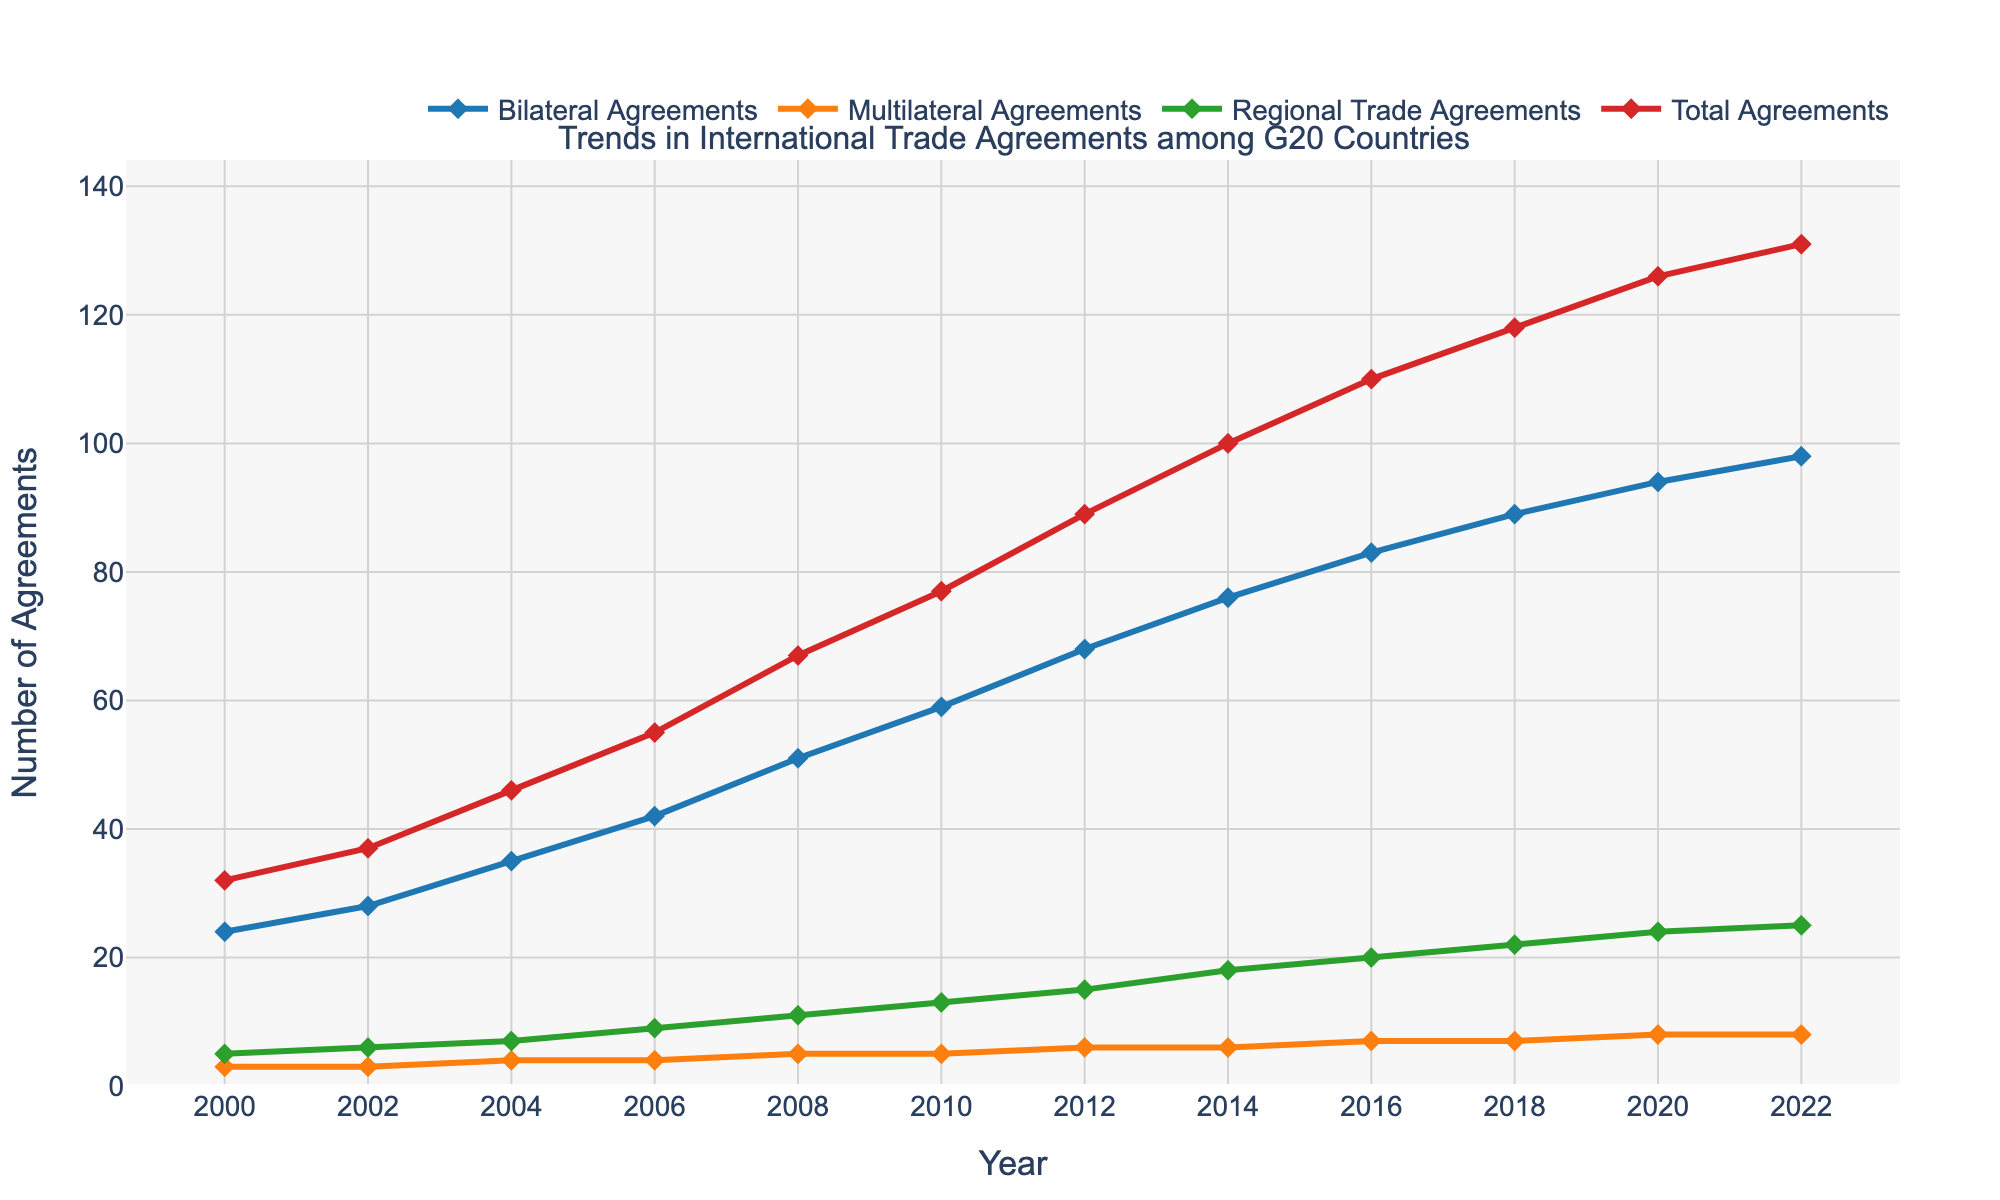What is the trend in the number of bilateral agreements from 2000 to 2022? Bilateral agreements show an increasing trend from 24 in 2000 to 98 in 2022.
Answer: Increasing trend How many multilateral agreements were there in 2016 and how does this compare to 2022? In 2016, there were 7 multilateral agreements and in 2022, there were 8. So, the number increased by 1.
Answer: Increased by 1 Which year had the highest total number of trade agreements? The year with the highest total number of trade agreements is 2022 with 131 agreements.
Answer: 2022 How did the number of regional trade agreements change between 2008 and 2020? In 2008, there were 11 regional trade agreements and in 2020, there were 24. So, the number increased by 13.
Answer: Increased by 13 What is the average increase in bilateral agreements per year from 2000 to 2022? The number of bilateral agreements increased from 24 in 2000 to 98 in 2022, a span of 22 years. The increase is 98 - 24 = 74. Therefore, the average increase per year is 74/22 ≈ 3.36.
Answer: Approximately 3.36 Between which years did the total number of agreements see the largest increase? The total number of trade agreements saw the largest increase between 2012 and 2014, increasing from 89 to 100, which is an increase of 11 agreements.
Answer: 2012 to 2014 What was the difference in the number of bilateral agreements between 2006 and 2018? In 2006, there were 42 bilateral agreements and in 2018, there were 89 bilateral agreements. The difference is 89 - 42 = 47.
Answer: 47 Which type of agreement shows the slowest rate of increase over the years? Multilateral agreements show the slowest rate of increase, starting with 3 in 2000 and growing to only 8 in 2022.
Answer: Multilateral Agreements What is the average number of regional trade agreements in the years 2000, 2004, 2008, 2012, 2016, and 2020? Adding the data points, 5, 7, 11, 15, 20, and 24, we get 82. Dividing by the number of data points, 6, we get 82/6 ≈ 13.67.
Answer: Approximately 13.67 What is the combined total number of trade agreements in the years 2006 and 2010? In 2006, there were 55 total agreements and in 2010, there were 77. Combined, this is 55 + 77 = 132.
Answer: 132 